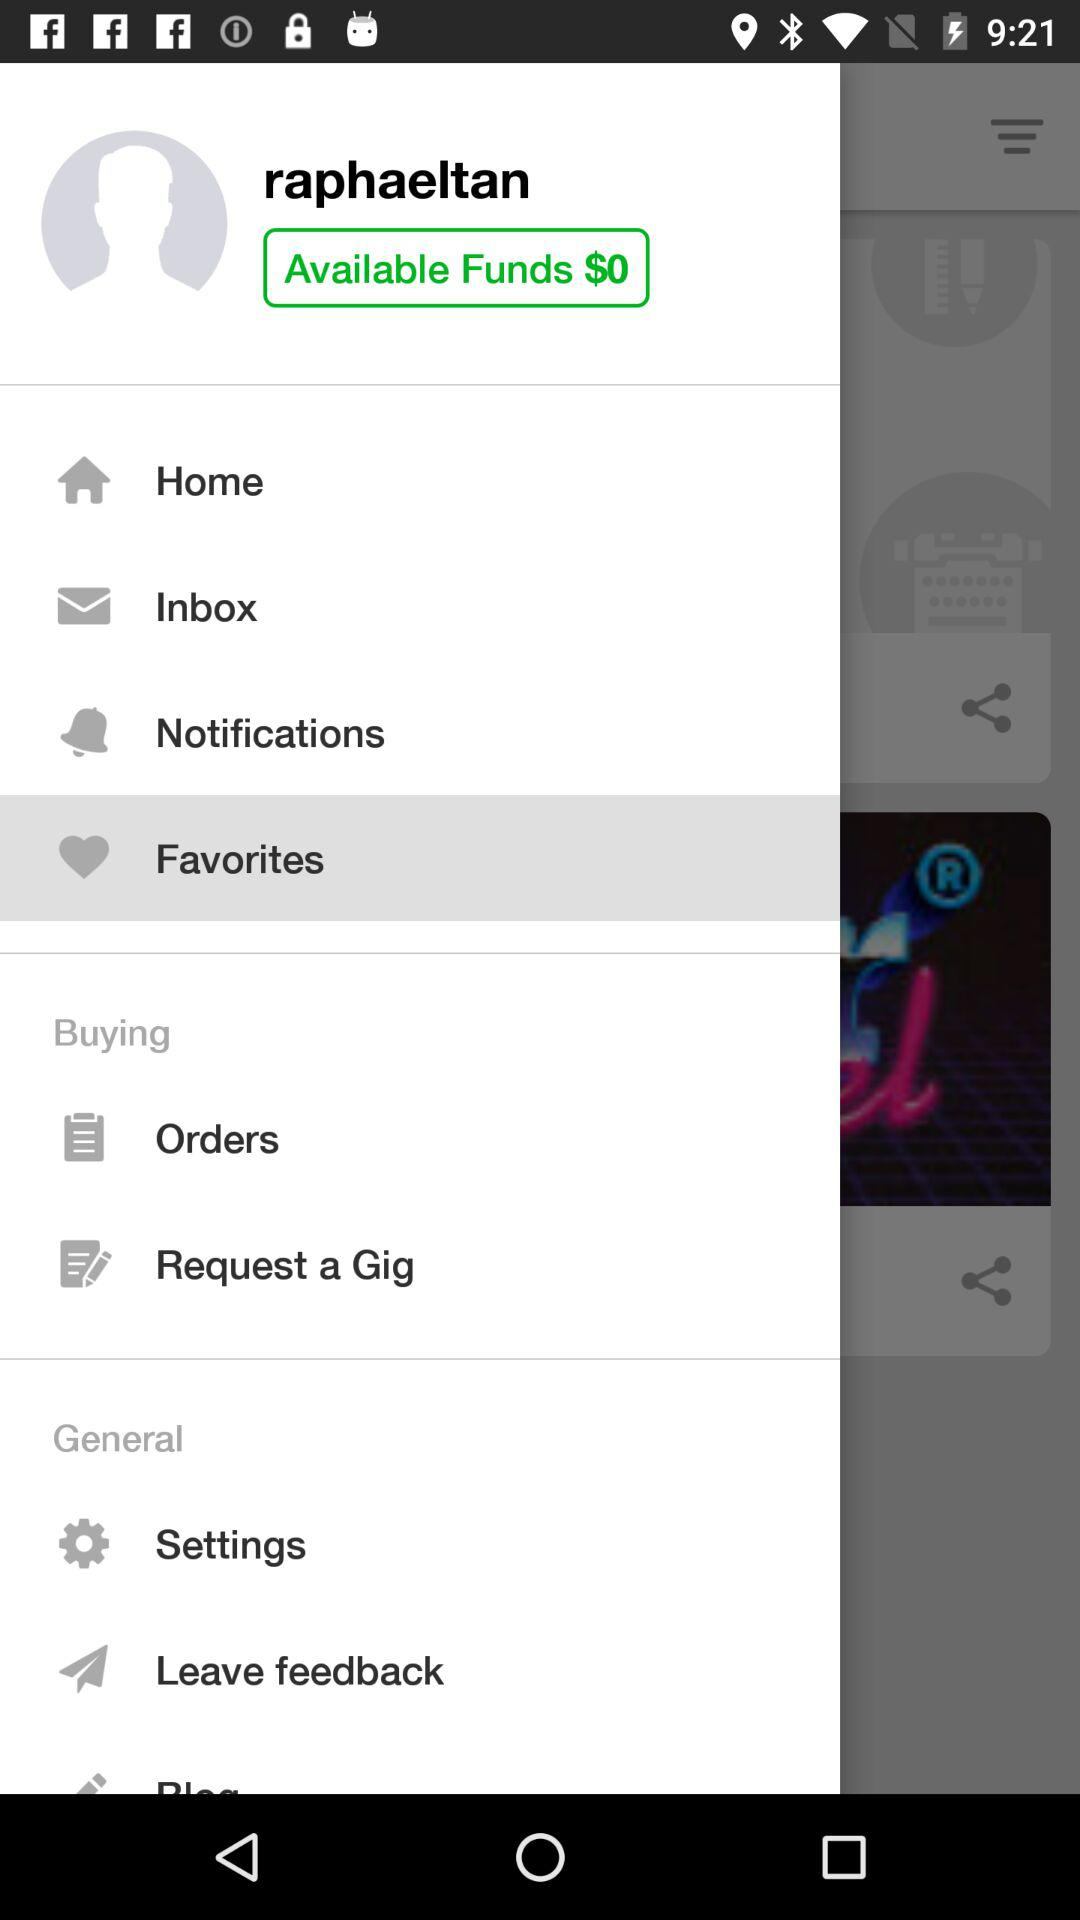What is the remaining amount of the available funds? The remaining amount of the available funds is $0. 